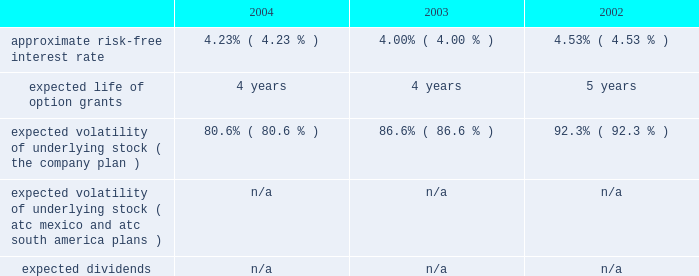American tower corporation and subsidiaries notes to consolidated financial statements 2014 ( continued ) pro forma disclosure 2014the company has adopted the disclosure-only provisions of sfas no .
123 , as amended by sfas no .
148 , and has presented such disclosure in note 1 .
The 201cfair value 201d of each option grant is estimated on the date of grant using the black-scholes option pricing model .
The weighted average fair values of the company 2019s options granted during 2004 , 2003 and 2002 were $ 7.05 , $ 6.32 , and $ 2.23 per share , respectively .
Key assumptions used to apply this pricing model are as follows: .
Voluntary option exchanges 2014in february 2004 , the company issued to eligible employees 1032717 options with an exercise price of $ 11.19 per share , the fair market value of the class a common stock on the date of grant .
These options were issued in connection with a voluntary option exchange program entered into by the company in august 2003 , where the company accepted for surrender and cancelled options ( having an exercise price of $ 10.25 or greater ) to purchase 1831981 shares of its class a common stock .
The program , which was offered to both full and part-time employees , excluding the company 2019s executive officers and its directors , called for the grant ( at least six months and one day from the surrender date to employees still employed on that date ) of new options exercisable for two shares of class a common stock for every three shares of class a common stock issuable upon exercise of a surrendered option .
No options were granted to any employees who participated in the exchange offer between the cancellation date and the new grant date .
In may 2002 , the company issued to eligible employees 2027612 options with an exercise price of $ 3.84 per share , the fair market value of the class a common stock on the date of grant .
These options were issued in connection with a voluntary option exchange program entered into by the company in october 2001 , where the company accepted for surrender and cancelled options to purchase 3471211 shares of its class a common stock .
The program , which was offered to both full and part-time employees , excluding most of the company 2019s executive officers , called for the grant ( at least six months and one day from the surrender date to employees still employed on that date ) of new options exercisable for two shares of class a common stock for every three shares of class a common stock issuable upon exercise of a surrendered option .
No options were granted to any employees who participated in the exchange offer between the cancellation date and the new grant date .
Atc mexico holding stock option plan 2014the company maintains a stock option plan in its atc mexico subsidiary ( atc mexico plan ) .
The atc mexico plan provides for the issuance of options to officers , employees , directors and consultants of atc mexico .
The atc mexico plan limits the number of shares of common stock which may be granted to an aggregate of 360 shares , subject to adjustment based on changes in atc mexico 2019s capital structure .
During 2002 , atc mexico granted options to purchase 318 shares of atc mexico common stock to officers and employees .
Such options were issued at one time with an exercise price of $ 10000 per share .
The exercise price per share was at fair market value as determined by the board of directors with the assistance of an independent appraisal performed at the company 2019s request .
The fair value of atc mexico plan options granted during 2002 were $ 3611 per share as determined by using the black-scholes option pricing model .
As described in note 10 , all outstanding options were exercised in march 2004 .
No options under the atc mexico plan were granted in 2004 or 2003 , or exercised or cancelled in 2003 or 2002 , and no options were exercisable as of december 31 , 2003 or 2002 .
( see note 10. ) .
Based on the black-scholes option pricing model what was the percent of the change in the option prices from 2003 to 2004? 
Computations: ((7.05 / 6.32) / 6.32)
Answer: 0.1765. 